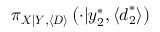<formula> <loc_0><loc_0><loc_500><loc_500>\pi _ { X | Y , \langle D \rangle } \left ( \cdot | y _ { 2 } ^ { * } , \langle d _ { 2 } ^ { * } \rangle \right )</formula> 